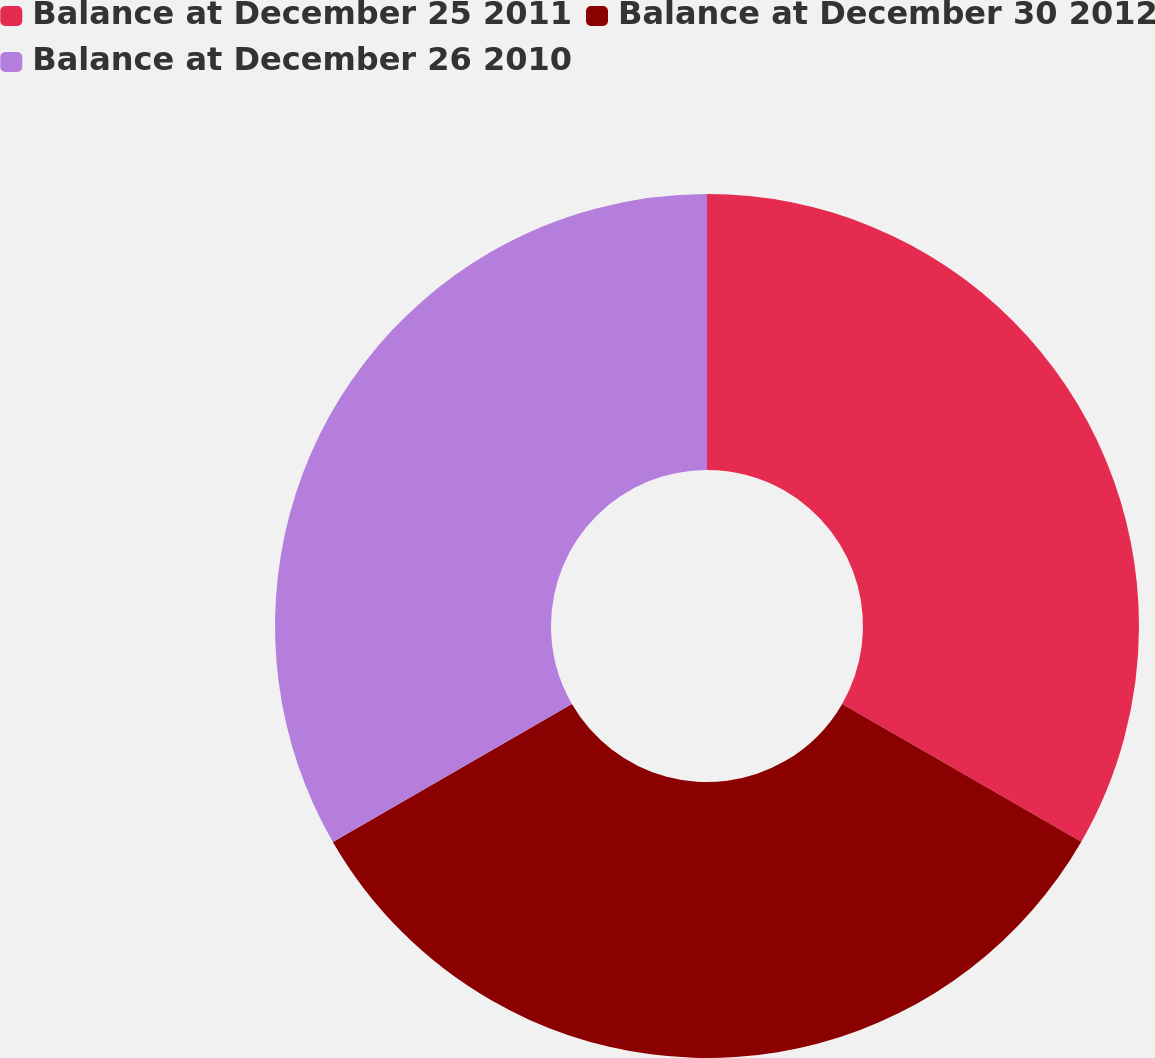Convert chart to OTSL. <chart><loc_0><loc_0><loc_500><loc_500><pie_chart><fcel>Balance at December 25 2011<fcel>Balance at December 30 2012<fcel>Balance at December 26 2010<nl><fcel>33.32%<fcel>33.35%<fcel>33.33%<nl></chart> 